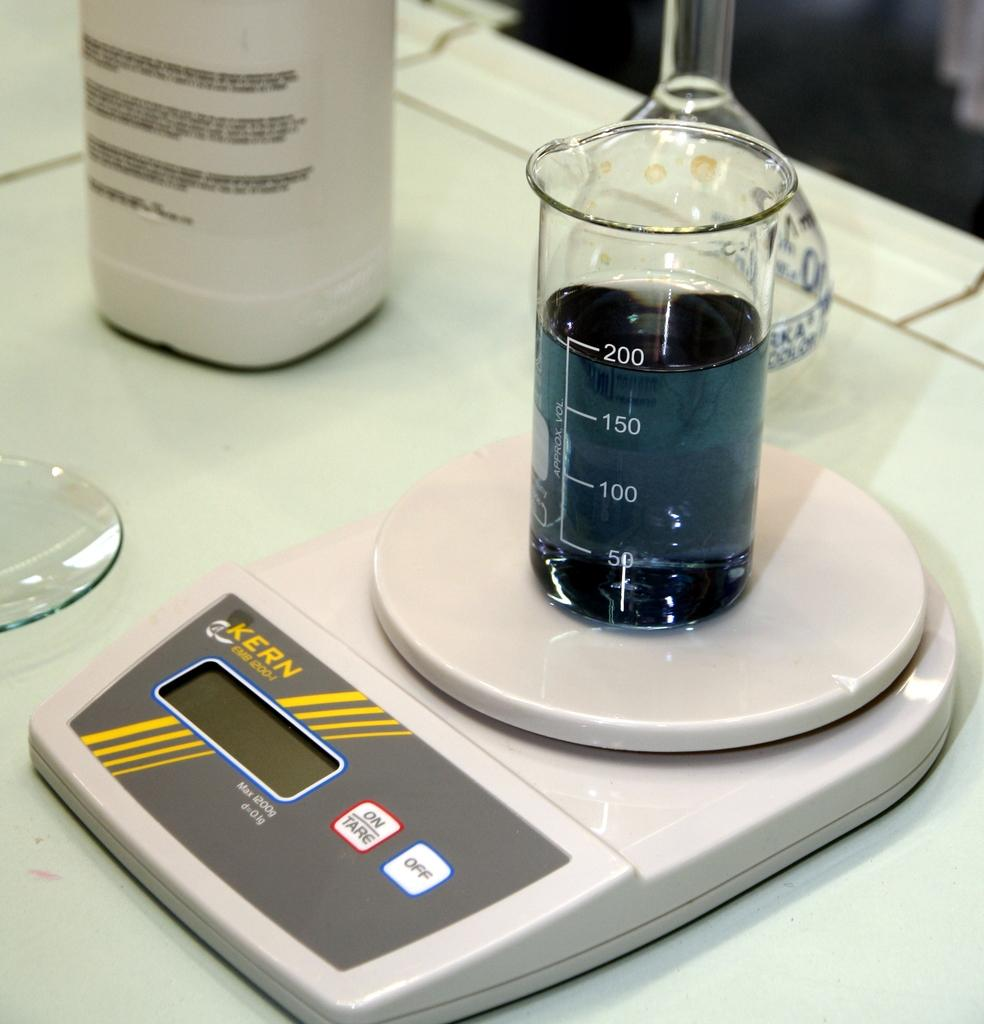What is the main structure visible in the image? There is a platform in the image. What can be seen on top of the platform? There is a glass and a beaker on the platform. Are there any other objects present on the platform? Yes, there are other objects on the platform. Can you tell me how many lizards are crawling on the platform in the image? There are no lizards present on the platform in the image. What type of parent is shown interacting with the objects on the platform? There is no parent present in the image; it only features a platform with various objects on it. 